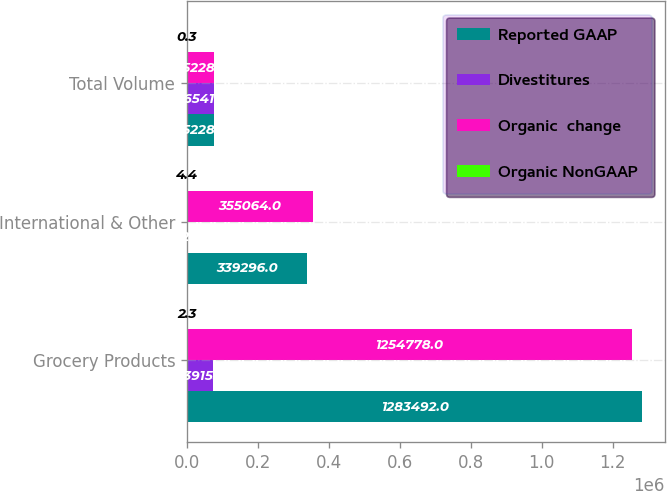Convert chart to OTSL. <chart><loc_0><loc_0><loc_500><loc_500><stacked_bar_chart><ecel><fcel>Grocery Products<fcel>International & Other<fcel>Total Volume<nl><fcel>Reported GAAP<fcel>1.28349e+06<fcel>339296<fcel>75228<nl><fcel>Divestitures<fcel>73915<fcel>2626<fcel>76541<nl><fcel>Organic  change<fcel>1.25478e+06<fcel>355064<fcel>75228<nl><fcel>Organic NonGAAP<fcel>2.3<fcel>4.4<fcel>0.3<nl></chart> 